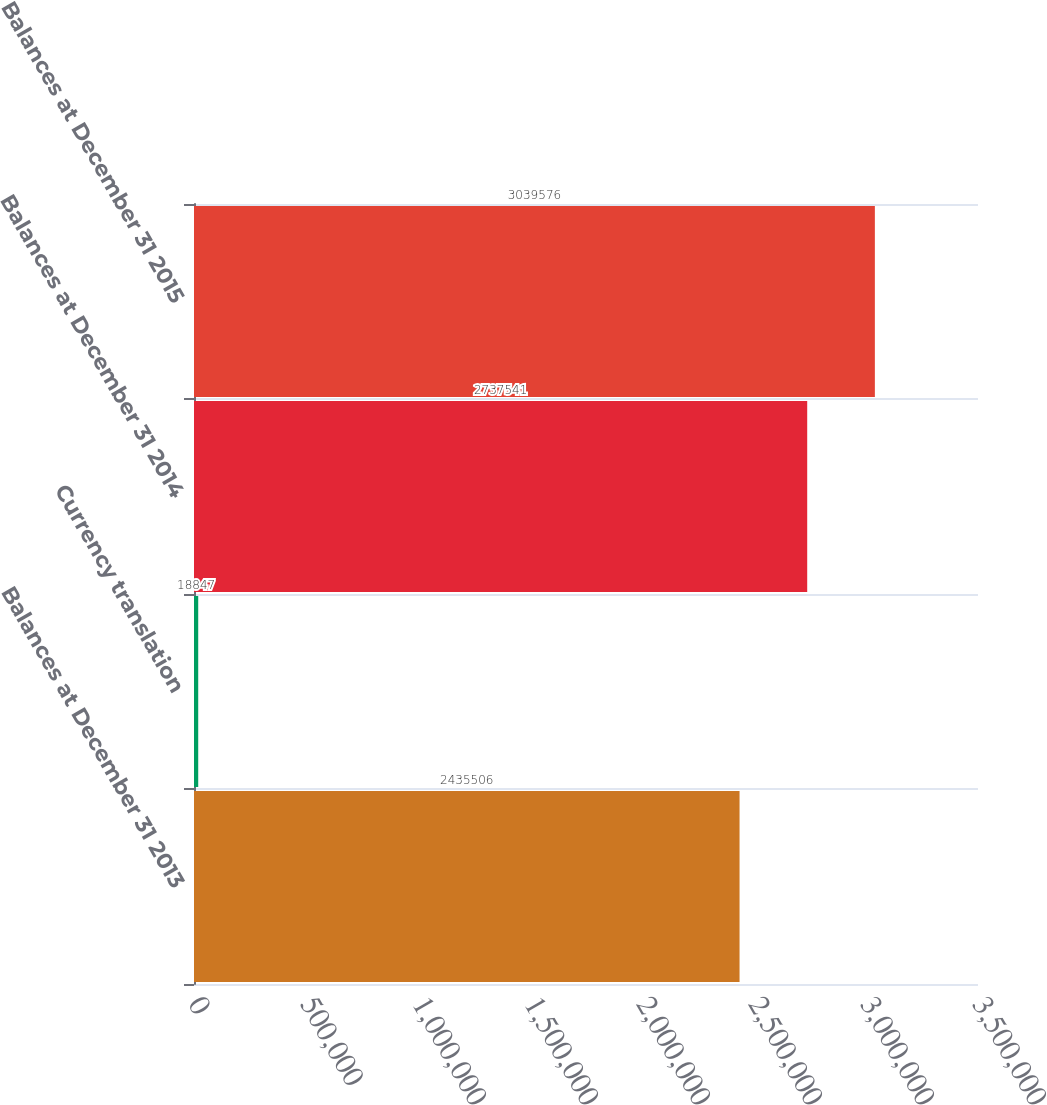Convert chart. <chart><loc_0><loc_0><loc_500><loc_500><bar_chart><fcel>Balances at December 31 2013<fcel>Currency translation<fcel>Balances at December 31 2014<fcel>Balances at December 31 2015<nl><fcel>2.43551e+06<fcel>18847<fcel>2.73754e+06<fcel>3.03958e+06<nl></chart> 